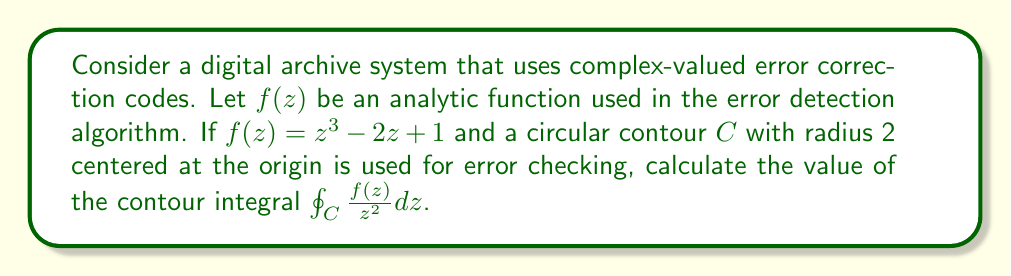Can you solve this math problem? To solve this problem, we'll use Cauchy's Integral Formula and the properties of analytic functions. Let's break it down step-by-step:

1) First, we need to determine if the function $\frac{f(z)}{z^2}$ has any singularities inside the contour $C$. 
   The only potential singularity is at $z=0$.

2) We can rewrite $\frac{f(z)}{z^2}$ as:

   $$\frac{f(z)}{z^2} = \frac{z^3 - 2z + 1}{z^2} = z - 2\frac{1}{z} + \frac{1}{z^2}$$

3) This shows that $z=0$ is indeed a pole of order 2.

4) According to Cauchy's Integral Formula for derivatives, for an analytic function $g(z)$:

   $$\oint_C \frac{g(z)}{(z-a)^{n+1}} dz = \frac{2\pi i}{n!} g^{(n)}(a)$$

   where $g^{(n)}(a)$ is the $n$-th derivative of $g$ at $a$.

5) In our case, $g(z) = z^3 - 2z + 1$, $a=0$, and $n=1$.

6) We need to find $g'(0)$:
   
   $g'(z) = 3z^2 - 2$
   $g'(0) = -2$

7) Applying the formula:

   $$\oint_C \frac{f(z)}{z^2} dz = 2\pi i \cdot g'(0) = 2\pi i \cdot (-2) = -4\pi i$$

This result shows that the contour integral is non-zero, which in the context of error detection could indicate the presence of an error in the digital archive data.
Answer: $-4\pi i$ 